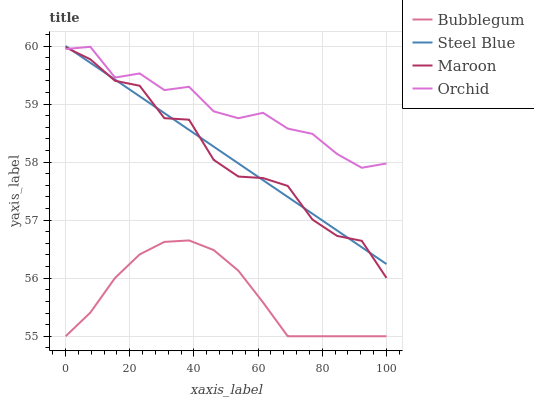Does Bubblegum have the minimum area under the curve?
Answer yes or no. Yes. Does Orchid have the maximum area under the curve?
Answer yes or no. Yes. Does Steel Blue have the minimum area under the curve?
Answer yes or no. No. Does Steel Blue have the maximum area under the curve?
Answer yes or no. No. Is Steel Blue the smoothest?
Answer yes or no. Yes. Is Maroon the roughest?
Answer yes or no. Yes. Is Bubblegum the smoothest?
Answer yes or no. No. Is Bubblegum the roughest?
Answer yes or no. No. Does Steel Blue have the lowest value?
Answer yes or no. No. Does Steel Blue have the highest value?
Answer yes or no. Yes. Does Bubblegum have the highest value?
Answer yes or no. No. Is Bubblegum less than Maroon?
Answer yes or no. Yes. Is Orchid greater than Bubblegum?
Answer yes or no. Yes. Does Bubblegum intersect Maroon?
Answer yes or no. No. 